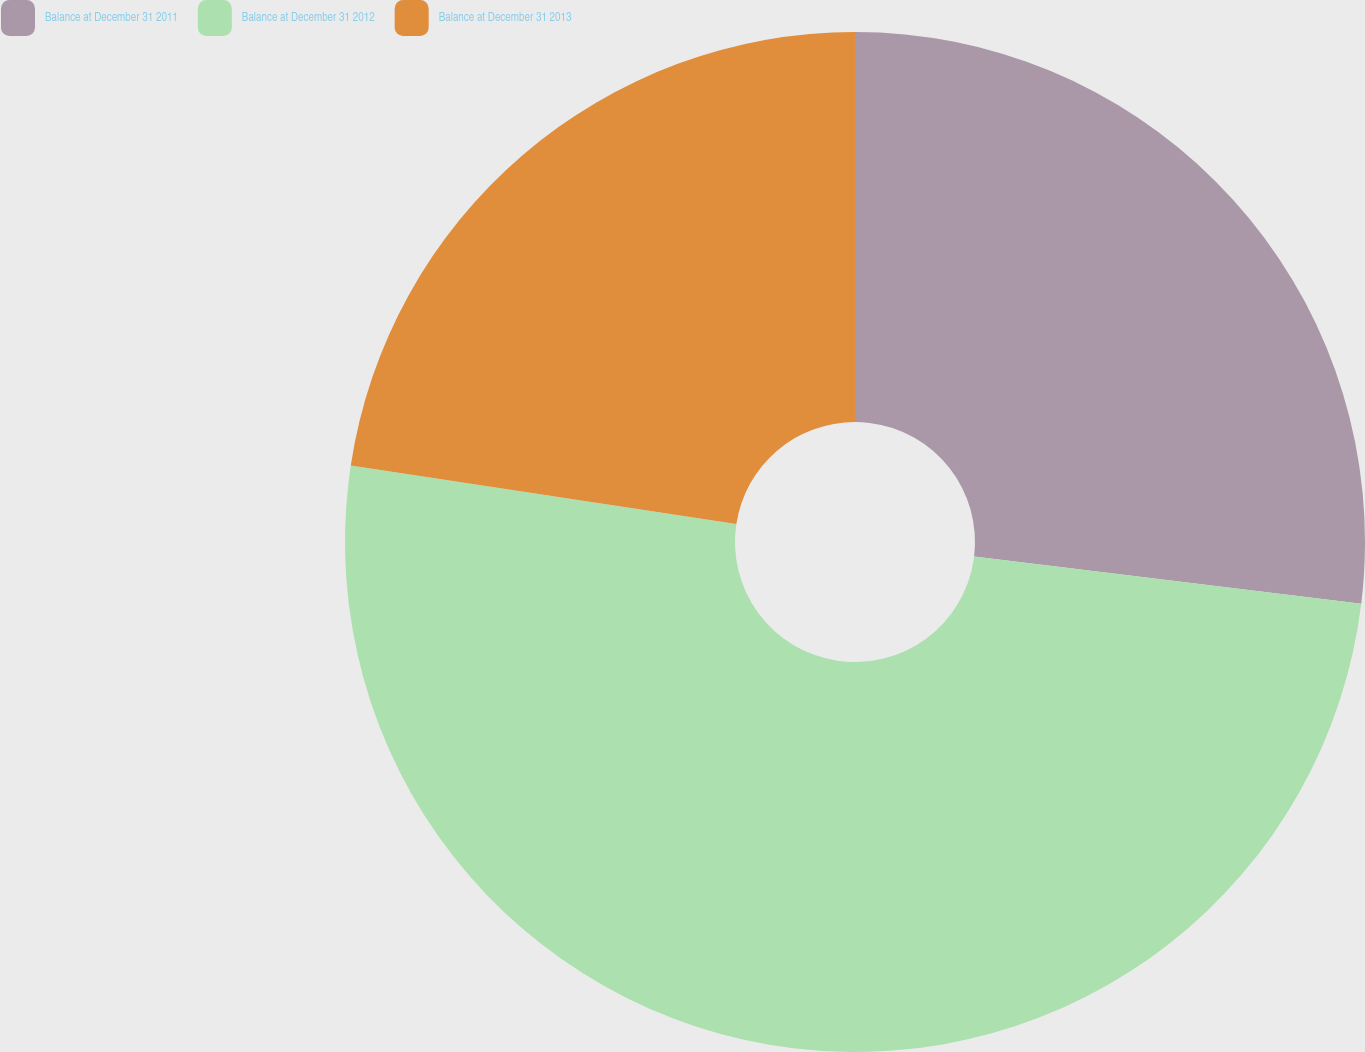Convert chart. <chart><loc_0><loc_0><loc_500><loc_500><pie_chart><fcel>Balance at December 31 2011<fcel>Balance at December 31 2012<fcel>Balance at December 31 2013<nl><fcel>26.93%<fcel>50.46%<fcel>22.6%<nl></chart> 